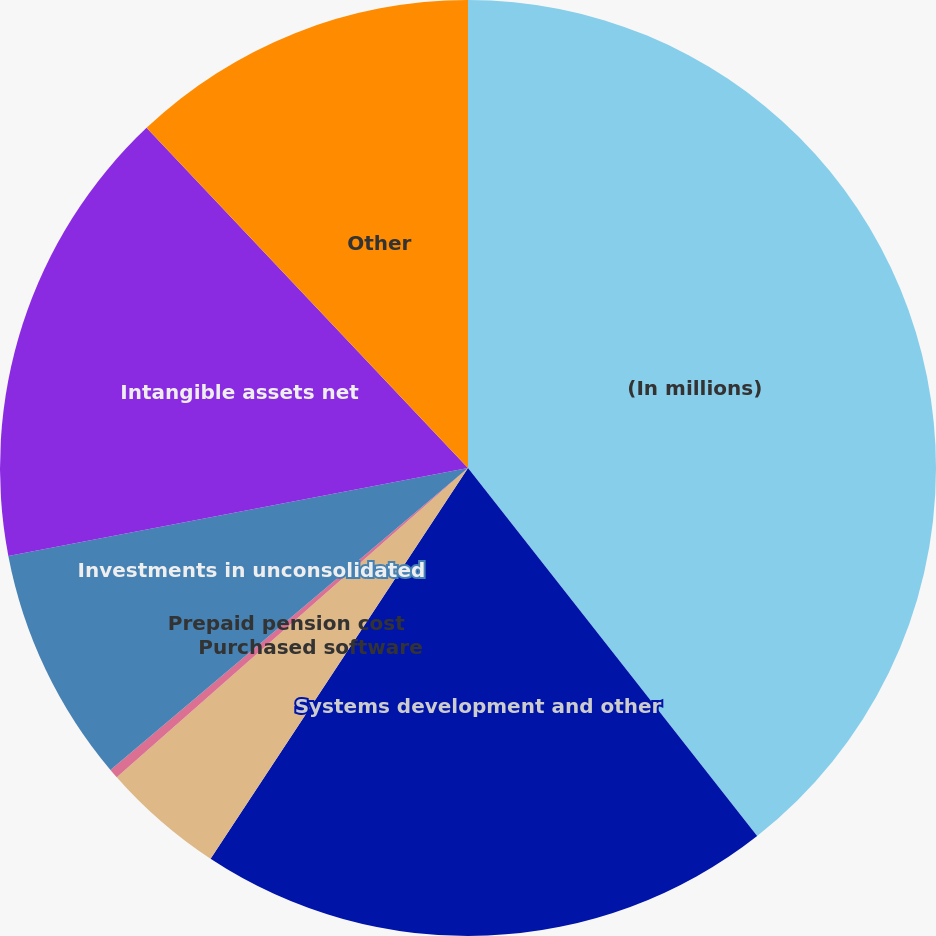Convert chart to OTSL. <chart><loc_0><loc_0><loc_500><loc_500><pie_chart><fcel>(In millions)<fcel>Systems development and other<fcel>Purchased software<fcel>Prepaid pension cost<fcel>Investments in unconsolidated<fcel>Intangible assets net<fcel>Other<nl><fcel>39.4%<fcel>19.87%<fcel>4.24%<fcel>0.33%<fcel>8.15%<fcel>15.96%<fcel>12.05%<nl></chart> 